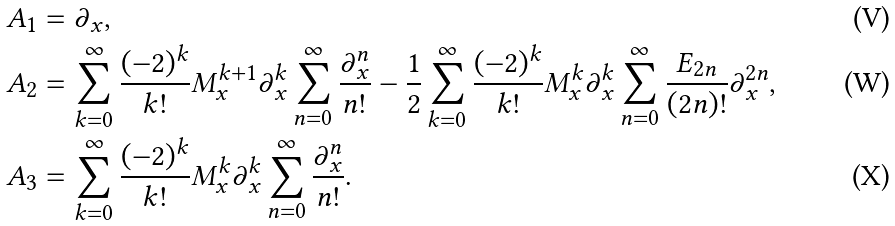Convert formula to latex. <formula><loc_0><loc_0><loc_500><loc_500>A _ { 1 } & = \partial _ { x } , \\ A _ { 2 } & = \sum _ { k = 0 } ^ { \infty } \frac { ( - 2 ) ^ { k } } { k ! } M _ { x } ^ { k + 1 } \partial _ { x } ^ { k } \sum _ { n = 0 } ^ { \infty } \frac { \partial _ { x } ^ { n } } { n ! } - \frac { 1 } { 2 } \sum _ { k = 0 } ^ { \infty } \frac { ( - 2 ) ^ { k } } { k ! } M _ { x } ^ { k } \partial _ { x } ^ { k } \sum _ { n = 0 } ^ { \infty } \frac { E _ { 2 n } } { ( 2 n ) ! } \partial _ { x } ^ { 2 n } , \\ A _ { 3 } & = \sum _ { k = 0 } ^ { \infty } \frac { ( - 2 ) ^ { k } } { k ! } M _ { x } ^ { k } \partial _ { x } ^ { k } \sum _ { n = 0 } ^ { \infty } \frac { \partial _ { x } ^ { n } } { n ! } .</formula> 